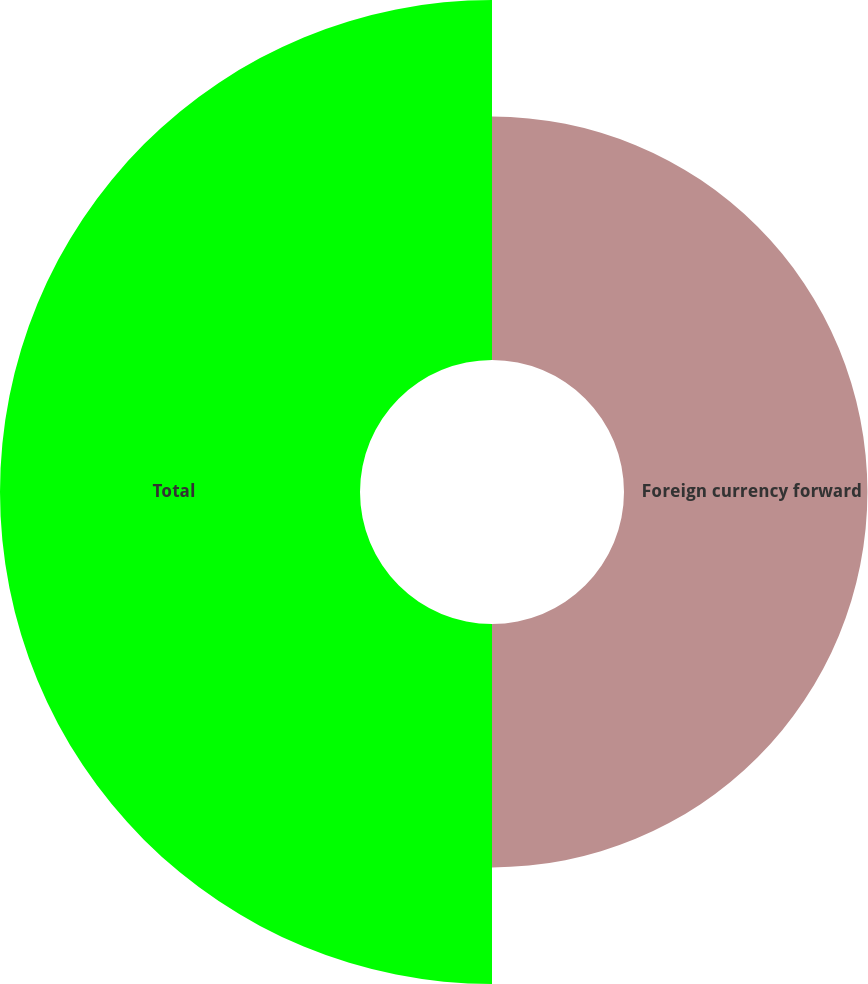Convert chart. <chart><loc_0><loc_0><loc_500><loc_500><pie_chart><fcel>Foreign currency forward<fcel>Total<nl><fcel>40.34%<fcel>59.66%<nl></chart> 